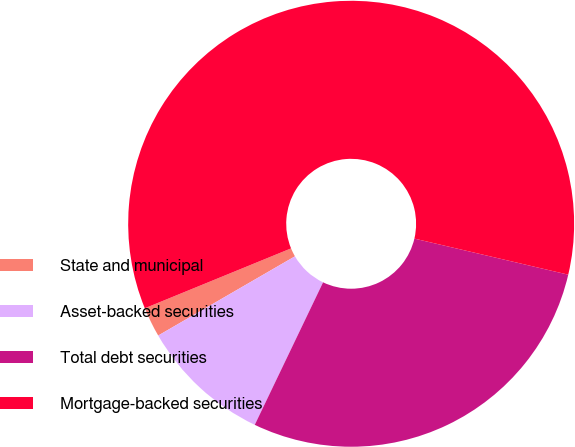Convert chart. <chart><loc_0><loc_0><loc_500><loc_500><pie_chart><fcel>State and municipal<fcel>Asset-backed securities<fcel>Total debt securities<fcel>Mortgage-backed securities<nl><fcel>2.17%<fcel>9.53%<fcel>28.45%<fcel>59.85%<nl></chart> 